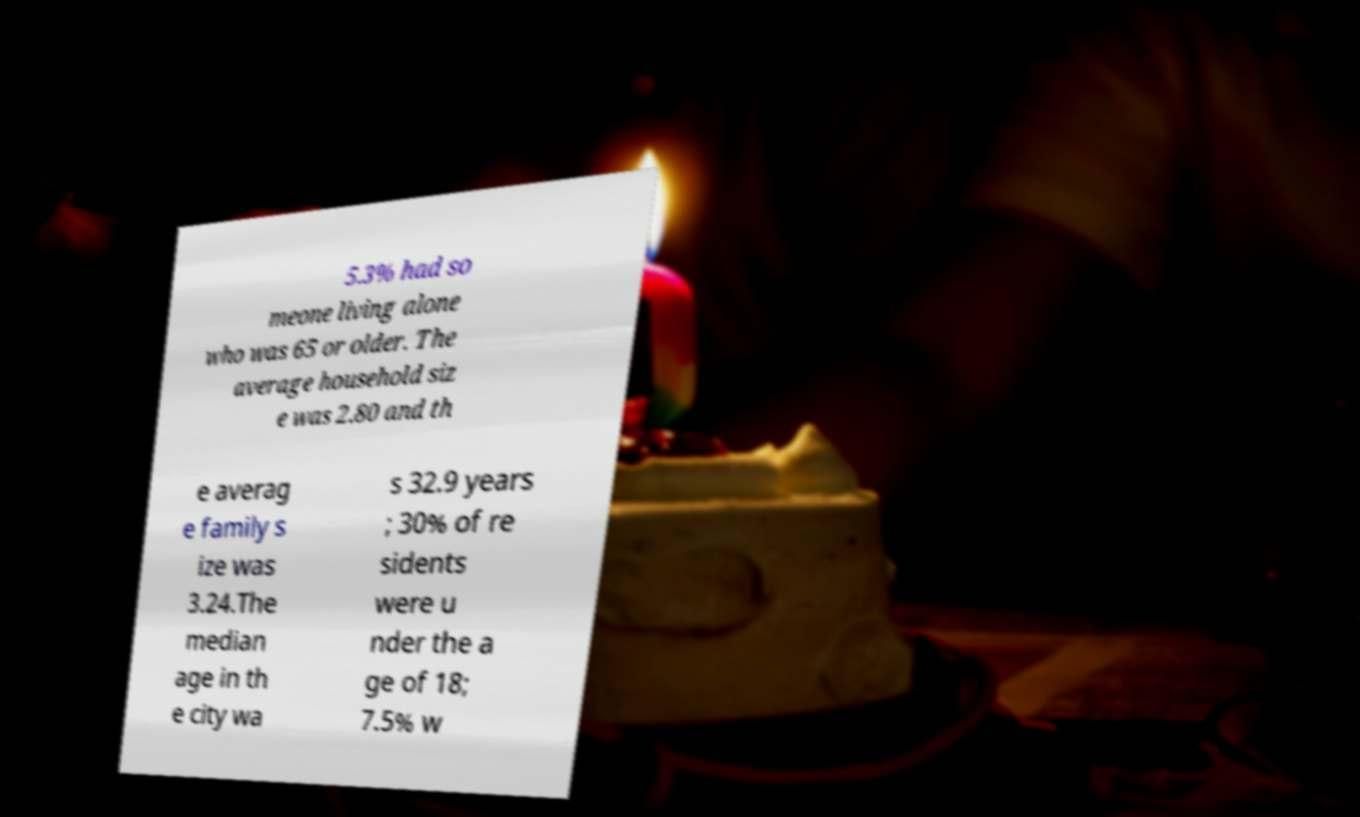Could you assist in decoding the text presented in this image and type it out clearly? 5.3% had so meone living alone who was 65 or older. The average household siz e was 2.80 and th e averag e family s ize was 3.24.The median age in th e city wa s 32.9 years ; 30% of re sidents were u nder the a ge of 18; 7.5% w 